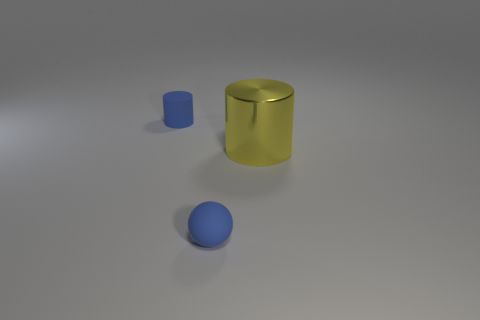Are there any other things that have the same material as the big yellow object?
Your answer should be compact. No. Are there any other things that have the same size as the yellow cylinder?
Your response must be concise. No. There is another tiny thing that is the same shape as the metal object; what color is it?
Provide a succinct answer. Blue. Is the number of tiny objects behind the yellow cylinder greater than the number of things that are in front of the small sphere?
Your answer should be very brief. Yes. There is a cylinder in front of the blue matte object that is left of the small object that is in front of the yellow cylinder; what is its size?
Keep it short and to the point. Large. Is the material of the sphere the same as the cylinder behind the yellow metal thing?
Keep it short and to the point. Yes. How many other objects are there of the same material as the small ball?
Offer a terse response. 1. How many other big blue shiny objects have the same shape as the large thing?
Make the answer very short. 0. What color is the thing that is on the left side of the yellow object and behind the tiny blue matte sphere?
Your response must be concise. Blue. What number of tiny blue rubber cylinders are there?
Offer a terse response. 1. 